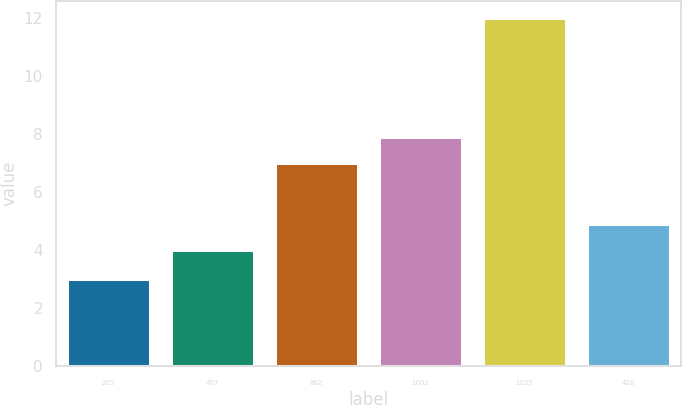Convert chart. <chart><loc_0><loc_0><loc_500><loc_500><bar_chart><fcel>205<fcel>497<fcel>862<fcel>1002<fcel>1025<fcel>428<nl><fcel>3<fcel>4<fcel>7<fcel>7.9<fcel>12<fcel>4.9<nl></chart> 